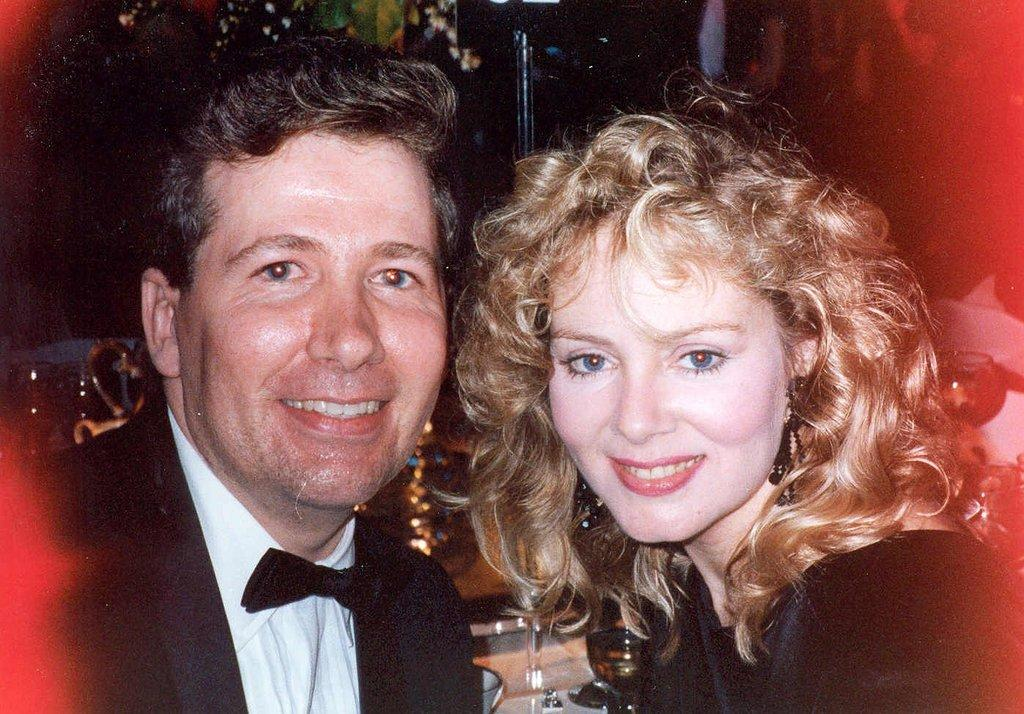Who can be seen in the foreground of the image? There is a man and a woman in the foreground of the image. What expressions do the man and woman have in the image? The man and woman are both smiling in the image. What can be seen in the background of the image? There are objects and lights in the background of the image. What type of bait is being used by the minister in the image? There is no minister or bait present in the image. How many planes can be seen flying in the background of the image? There are no planes visible in the image. 